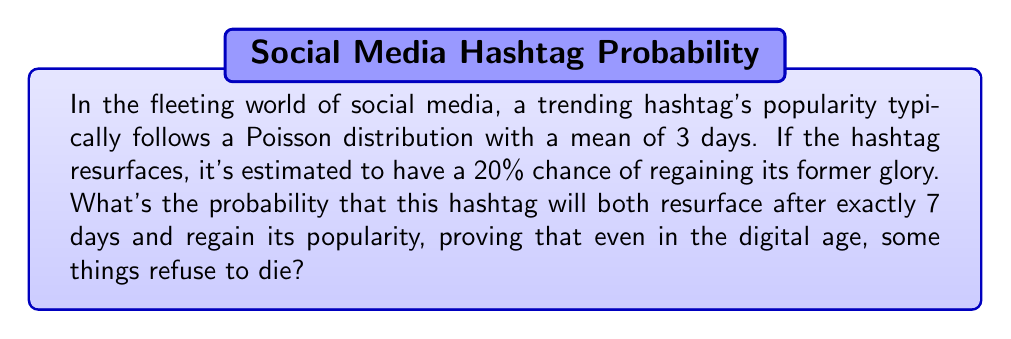Give your solution to this math problem. Let's break this down step-by-step:

1) The probability of the hashtag resurfacing after exactly 7 days follows a Poisson distribution. The probability mass function for a Poisson distribution is:

   $$P(X = k) = \frac{e^{-\lambda}\lambda^k}{k!}$$

   where $\lambda$ is the mean and $k$ is the number of occurrences.

2) In this case, $\lambda = 3$ and $k = 7$. Let's calculate:

   $$P(X = 7) = \frac{e^{-3}3^7}{7!}$$

3) Now, let's compute this:
   
   $$P(X = 7) = \frac{e^{-3} \cdot 2187}{5040} \approx 0.0149$$

4) The probability of regaining popularity is given as 20% or 0.2.

5) The probability of both events occurring is the product of their individual probabilities:

   $$P(\text{resurface after 7 days AND regain popularity}) = 0.0149 \cdot 0.2 = 0.00298$$

6) Converting to a percentage:

   $$0.00298 \cdot 100\% = 0.298\%$$
Answer: 0.298% 